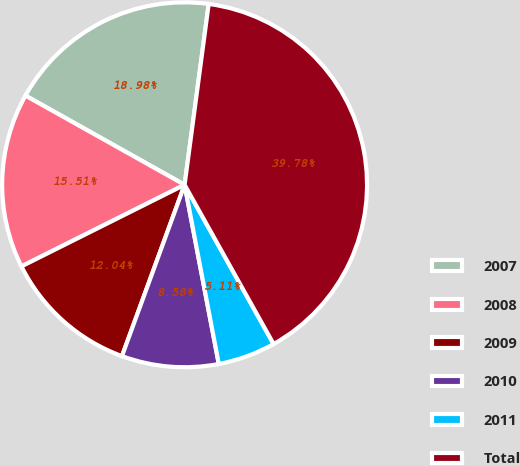Convert chart to OTSL. <chart><loc_0><loc_0><loc_500><loc_500><pie_chart><fcel>2007<fcel>2008<fcel>2009<fcel>2010<fcel>2011<fcel>Total<nl><fcel>18.98%<fcel>15.51%<fcel>12.04%<fcel>8.58%<fcel>5.11%<fcel>39.78%<nl></chart> 